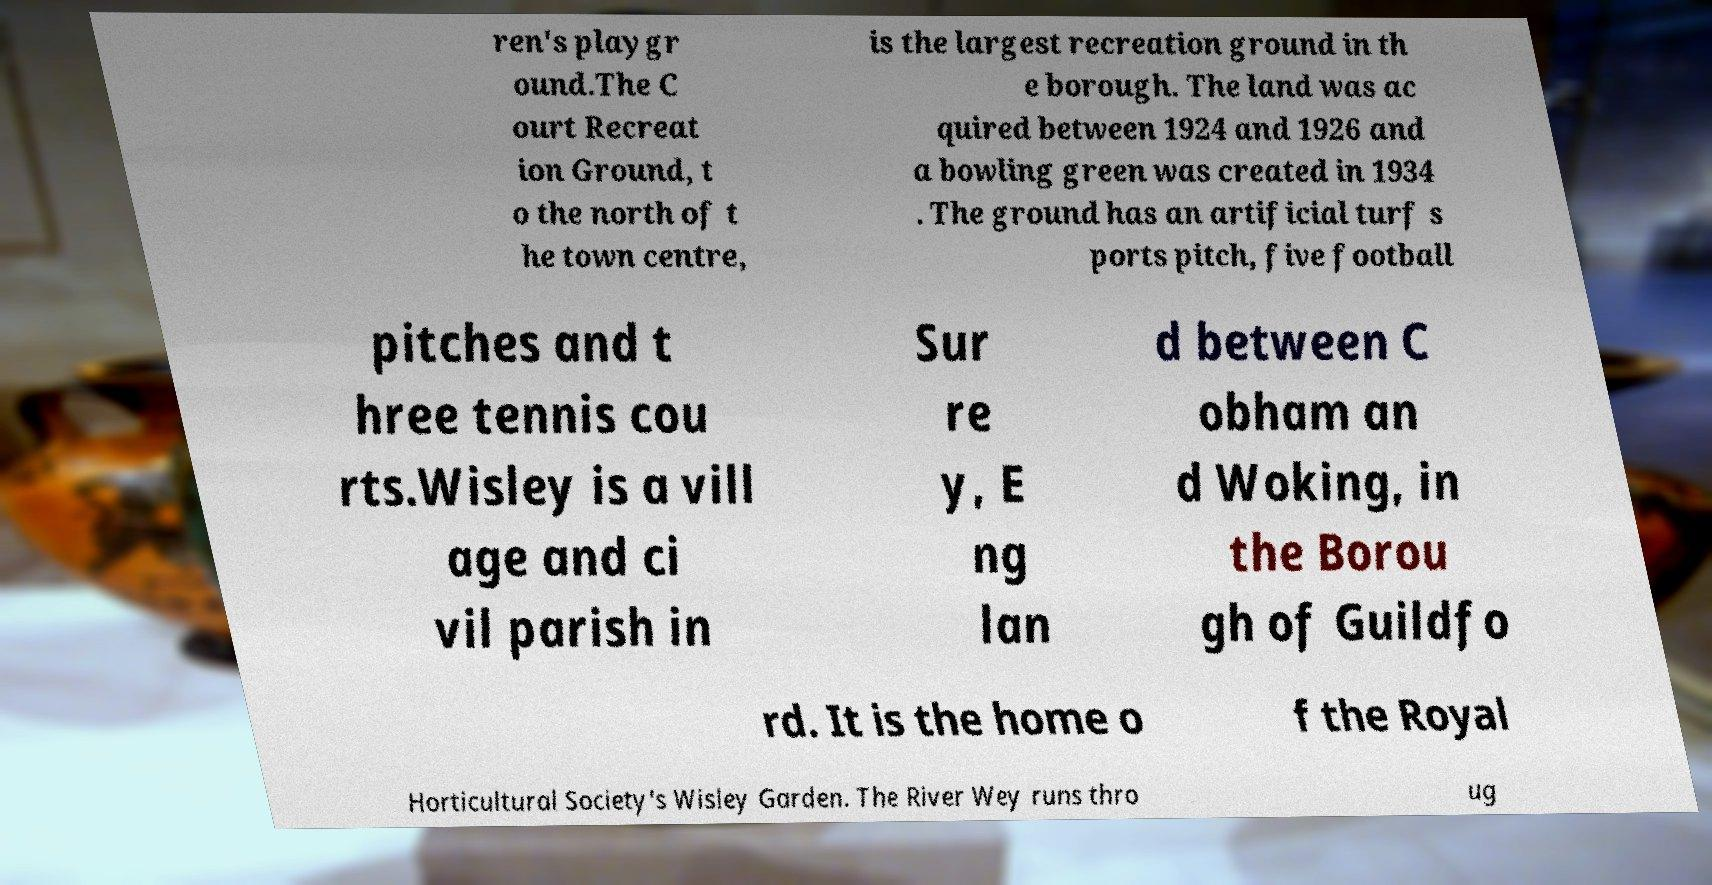There's text embedded in this image that I need extracted. Can you transcribe it verbatim? ren's playgr ound.The C ourt Recreat ion Ground, t o the north of t he town centre, is the largest recreation ground in th e borough. The land was ac quired between 1924 and 1926 and a bowling green was created in 1934 . The ground has an artificial turf s ports pitch, five football pitches and t hree tennis cou rts.Wisley is a vill age and ci vil parish in Sur re y, E ng lan d between C obham an d Woking, in the Borou gh of Guildfo rd. It is the home o f the Royal Horticultural Society's Wisley Garden. The River Wey runs thro ug 